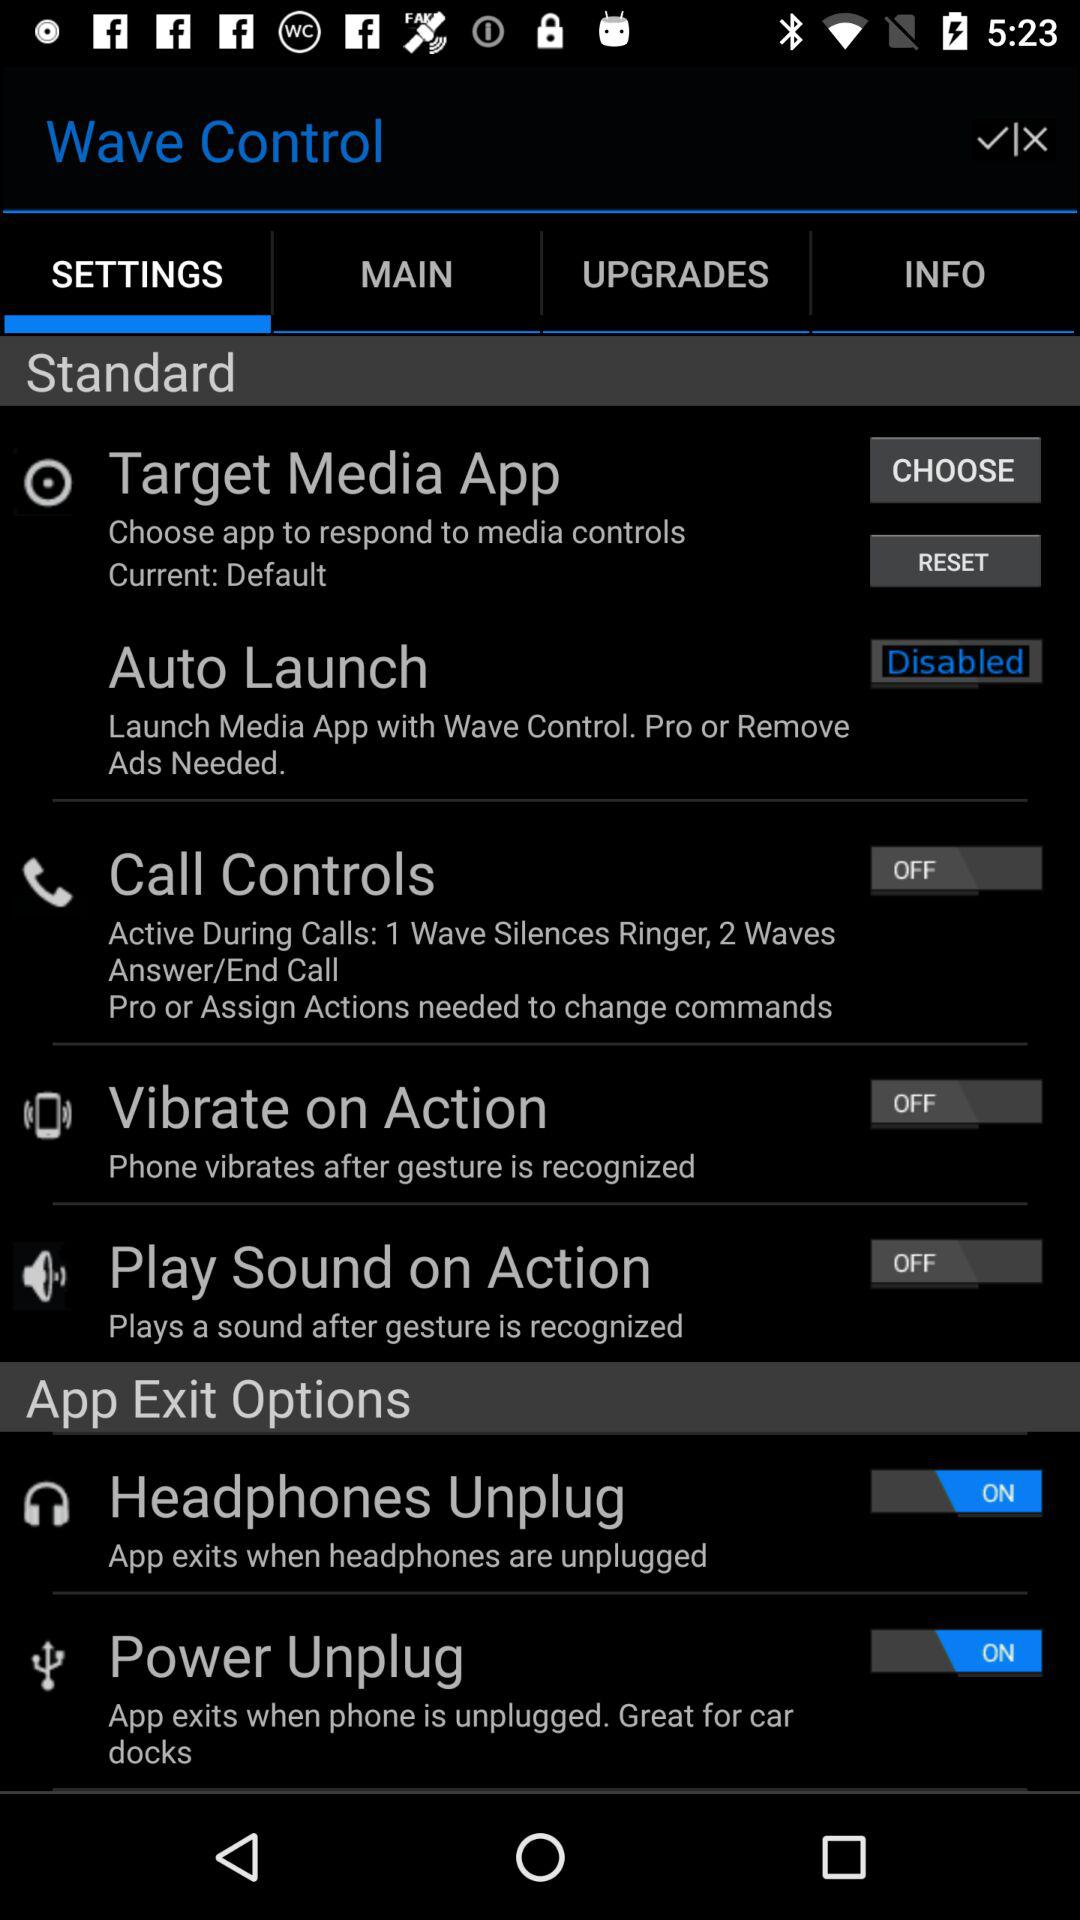How many of the app exit options have switches? There are two 'App Exit Options' that have switches displayed in the image. Both the 'Headphones Unplug' option and the 'Power Unplug' option have their switches turned on, as indicated by the blue color and the 'ON' position. 